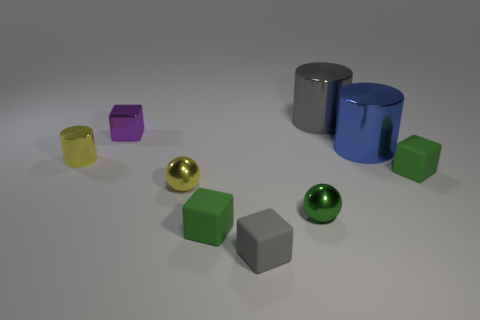Subtract all cyan spheres. How many green blocks are left? 2 Subtract all large shiny cylinders. How many cylinders are left? 1 Subtract 2 cubes. How many cubes are left? 2 Add 1 big metal objects. How many objects exist? 10 Subtract all gray cubes. How many cubes are left? 3 Subtract all cylinders. How many objects are left? 6 Subtract all purple cylinders. Subtract all blue spheres. How many cylinders are left? 3 Subtract all big gray objects. Subtract all metallic cylinders. How many objects are left? 5 Add 6 large blue things. How many large blue things are left? 7 Add 2 tiny objects. How many tiny objects exist? 9 